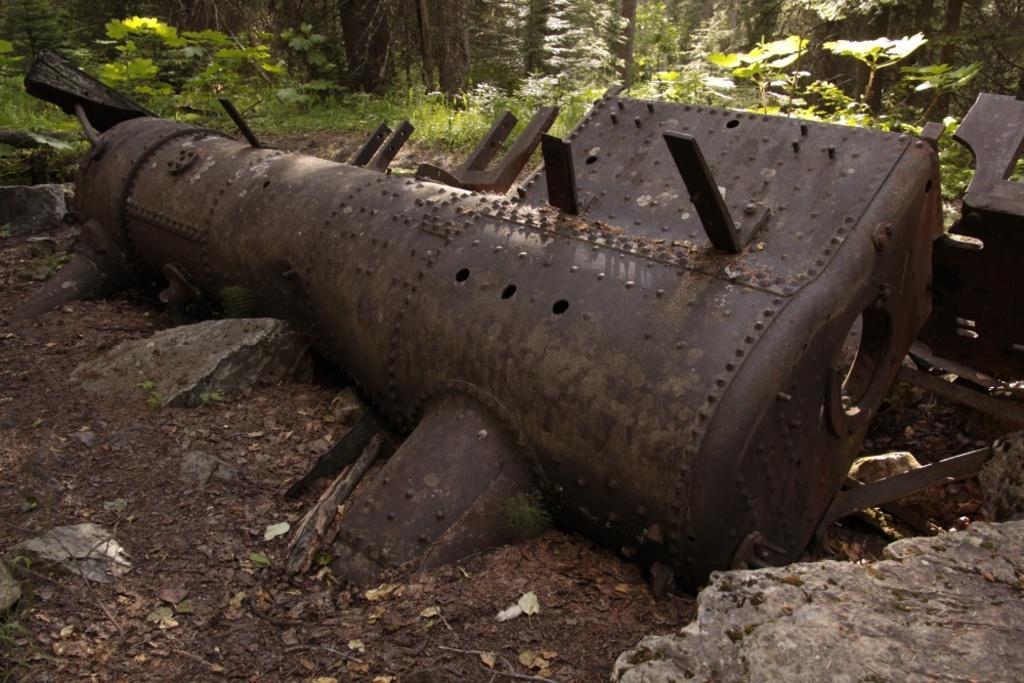How would you summarize this image in a sentence or two? In this image in the center there is an iron object, and at the bottom there is sand and some dry leaves and rocks. In the background there are some plants and trees. 